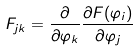<formula> <loc_0><loc_0><loc_500><loc_500>F _ { j k } = \frac { \partial } { \partial \varphi _ { k } } \frac { \partial F ( { \varphi _ { i } } ) } { \partial \varphi _ { j } }</formula> 